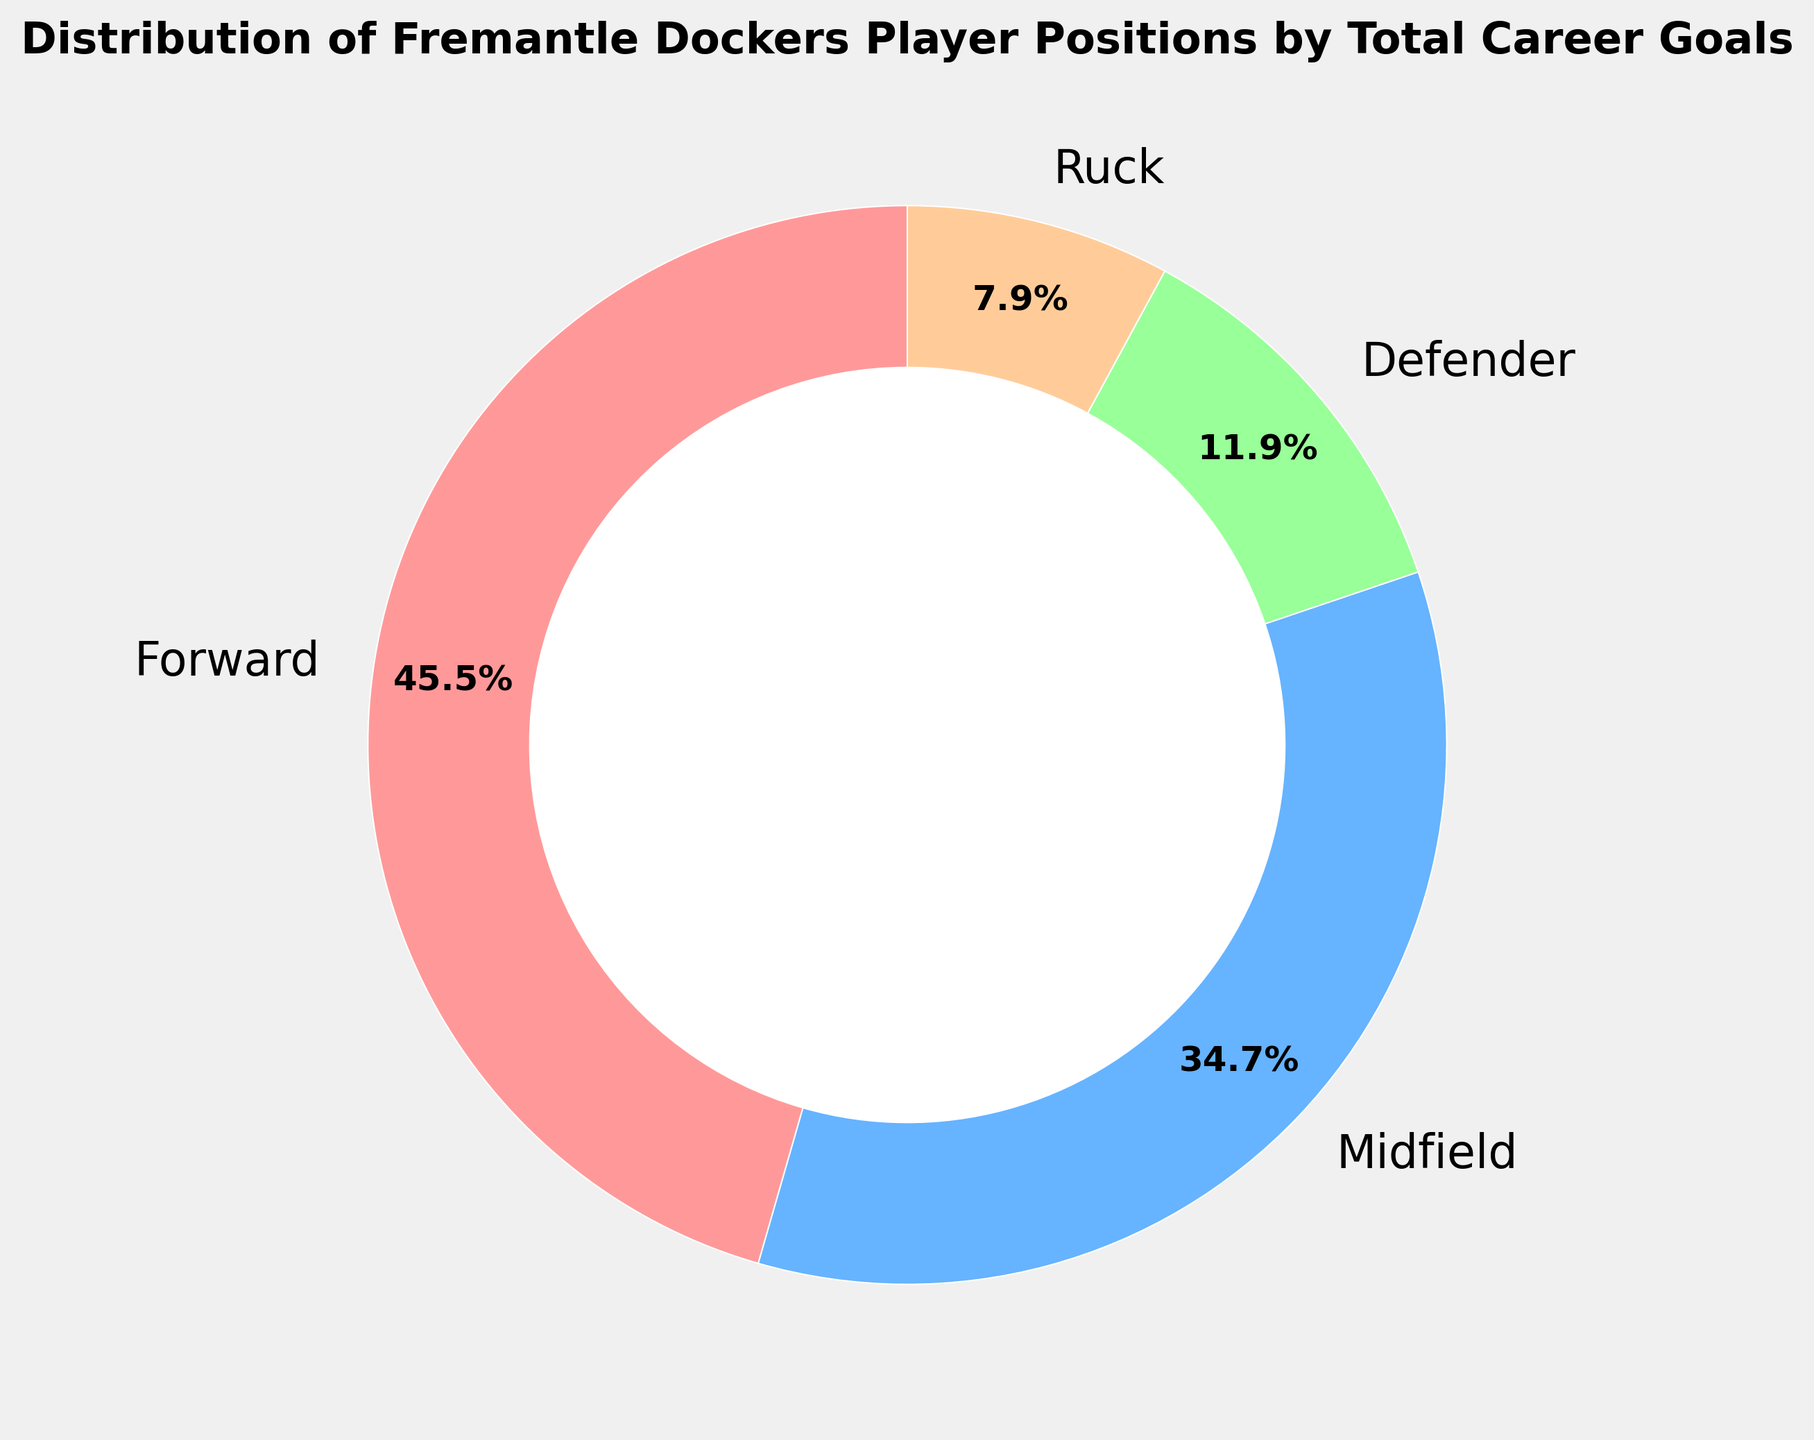What's the position with the highest number of career goals? The Forward position has the largest segment in the ring chart, indicating it has the most career goals.
Answer: Forward What's the total number of career goals scored by Defenders and Ruck players combined? Adding the total career goals for Defenders (600) and Ruck players (400) gives us 600 + 400 = 1000.
Answer: 1000 Which position has roughly half the total goals of the Midfield position? The Midfield position has 1750 goals and half of that amount is 875. The Ruck position has 400 goals, which is closest to roughly half of 1750.
Answer: Ruck Out of Forward and Defender, which position has fewer career goals, and by how much? The Forward position has 2300 goals, and the Defender position has 600 goals. The difference is 2300 - 600 = 1700 goals.
Answer: Defender, by 1700 goals How do the career goals of Midfield compare to that of Forward? The Midfield position has 1750 goals, while the Forward position has 2300 goals. Forward has more goals than Midfield.
Answer: Forward has more goals What percentage of total career goals were scored by Defenders? The chart shows percentages, and the Defenders' segment indicates they scored 10.0% of the total career goals.
Answer: 10.0% What is the total number of career goals scored by all positions? Adding the career goals for Forward (2300), Midfield (1750), Defender (600), and Ruck (400) gives 2300 + 1750 + 600 + 400 = 5050.
Answer: 5050 Which position has the smallest number of career goals, and how is it visually represented in the ring chart? The Ruck position has the smallest number of goals at 400. It's visually represented by the smallest segment in the ring chart.
Answer: Ruck, smallest segment Out of all the positions, which two have the closest number of career goals? Midfield (1750) and Defender (600) have the closest numbers when comparing the other pairs, with a difference of 1150 goals.
Answer: Midfield and Defender How many more goals does the position with the second-highest number of career goals have compared to the position with the fewest goals? Midfield has 1750 goals and the Ruck position has 400 goals. 1750 - 400 = 1350 more goals.
Answer: 1350 more goals 